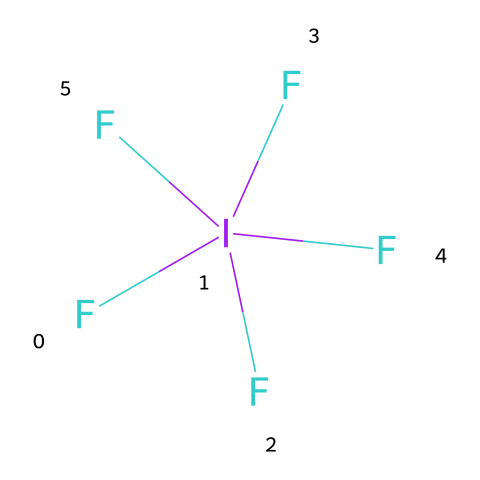how many fluorine atoms are present in iodine pentafluoride? The SMILES notation shows five fluorine atoms bonded to iodine. Each ‘F’ in the notation indicates a fluorine atom directly attached to the iodine.
Answer: five what is the central atom in iodine pentafluoride? In the SMILES representation, the ‘I’ symbolizes iodine, which serves as the central atom surrounded by the fluorine atoms.
Answer: iodine how many total bonds are there in iodine pentafluoride? Each fluorine atom forms a single bond with iodine, totaling five bonds, as indicated in the structure of the compound where iodine connects to each of the five fluorine atoms.
Answer: five what type of hybridization does iodine undergo in iodine pentafluoride? Iodine in iodine pentafluoride has five bonds, indicating sp3d hybridization, as it requires 5 hybrid orbitals (4 for bonding with fluorine and 1 for the lone pair).
Answer: sp3d is iodine pentafluoride a polar or nonpolar molecule? Iodine pentafluoride has a symmetrical arrangement of the bonds, which typically leads to a nonpolar character despite the individual bond polarities due to the electronegativity differences.
Answer: nonpolar what common application does iodine pentafluoride have? Iodine pentafluoride is primarily used in the process of uranium enrichment as a chemical reagent. This application involves supporting the separation process of isotopes of uranium.
Answer: uranium enrichment can iodine pentafluoride expel a ligand? Yes, due to its hypervalent nature, iodine pentafluoride can act as a Lewis acid, allowing it to expel a ligand and create a more stable compound in reactions.
Answer: yes 